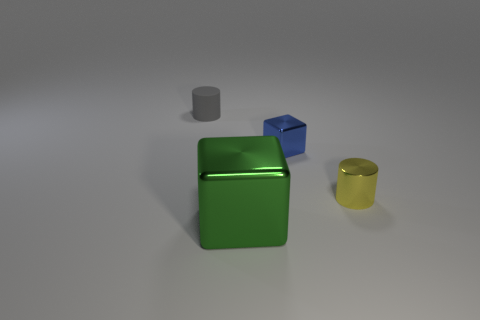Add 2 purple metallic cubes. How many objects exist? 6 Subtract 0 red cubes. How many objects are left? 4 Subtract 1 cubes. How many cubes are left? 1 Subtract all blue cubes. Subtract all brown spheres. How many cubes are left? 1 Subtract all cyan balls. How many purple blocks are left? 0 Subtract all tiny cyan cubes. Subtract all tiny gray rubber things. How many objects are left? 3 Add 1 large cubes. How many large cubes are left? 2 Add 4 green matte objects. How many green matte objects exist? 4 